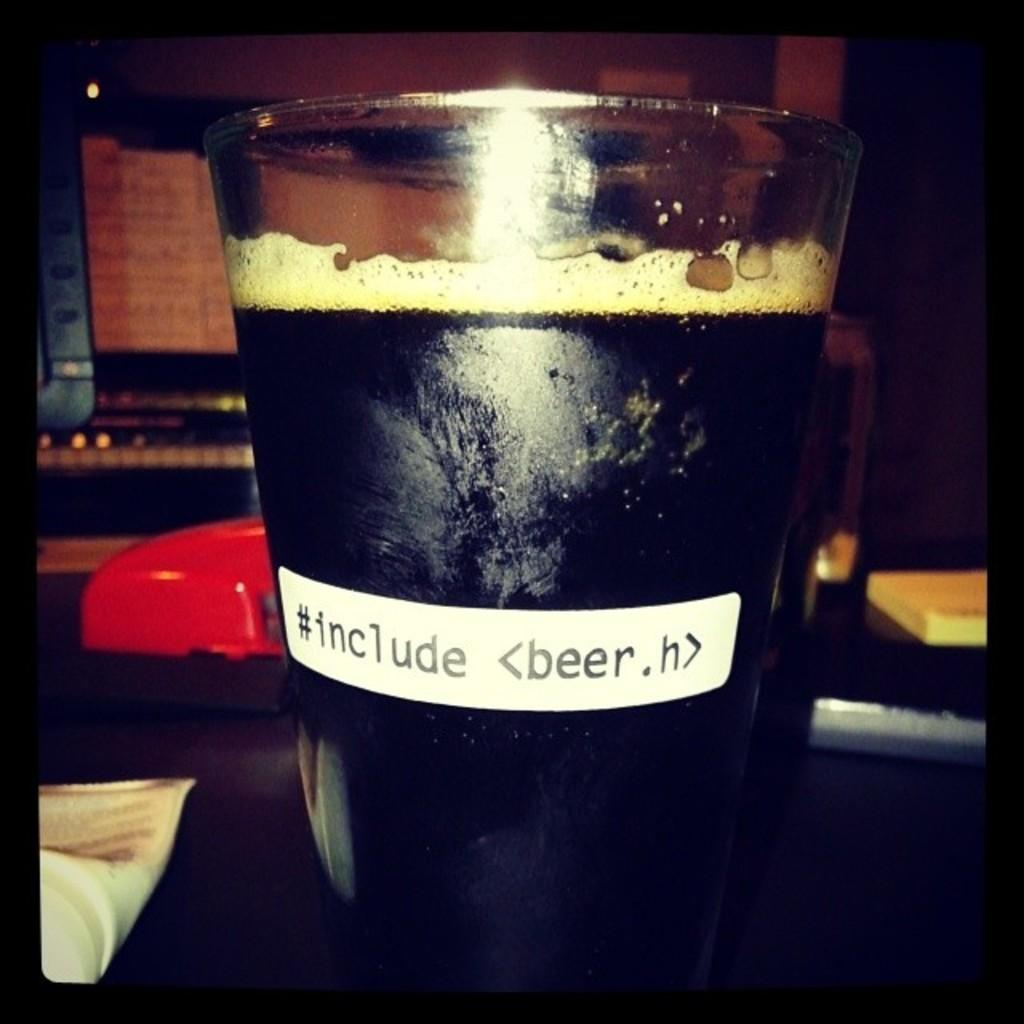<image>
Offer a succinct explanation of the picture presented. A glass that says #include <beer.h> sits on a table. 